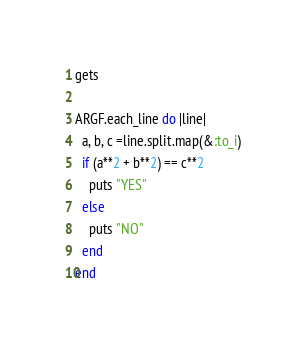Convert code to text. <code><loc_0><loc_0><loc_500><loc_500><_Ruby_>gets

ARGF.each_line do |line|
  a, b, c =line.split.map(&:to_i)
  if (a**2 + b**2) == c**2
    puts "YES"
  else
    puts "NO"
  end
end</code> 